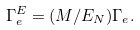Convert formula to latex. <formula><loc_0><loc_0><loc_500><loc_500>\Gamma _ { e } ^ { E } = ( M / E _ { N } ) \Gamma _ { e } .</formula> 